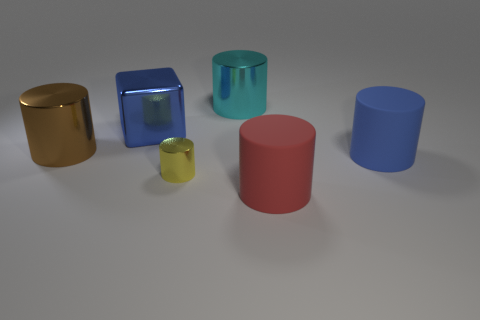Subtract all large shiny cylinders. How many cylinders are left? 3 Add 2 yellow metallic things. How many objects exist? 8 Subtract all red cylinders. How many cylinders are left? 4 Subtract all cylinders. How many objects are left? 1 Subtract 4 cylinders. How many cylinders are left? 1 Subtract 0 blue spheres. How many objects are left? 6 Subtract all blue cylinders. Subtract all gray cubes. How many cylinders are left? 4 Subtract all cyan blocks. How many blue cylinders are left? 1 Subtract all large gray matte cylinders. Subtract all blocks. How many objects are left? 5 Add 2 metal objects. How many metal objects are left? 6 